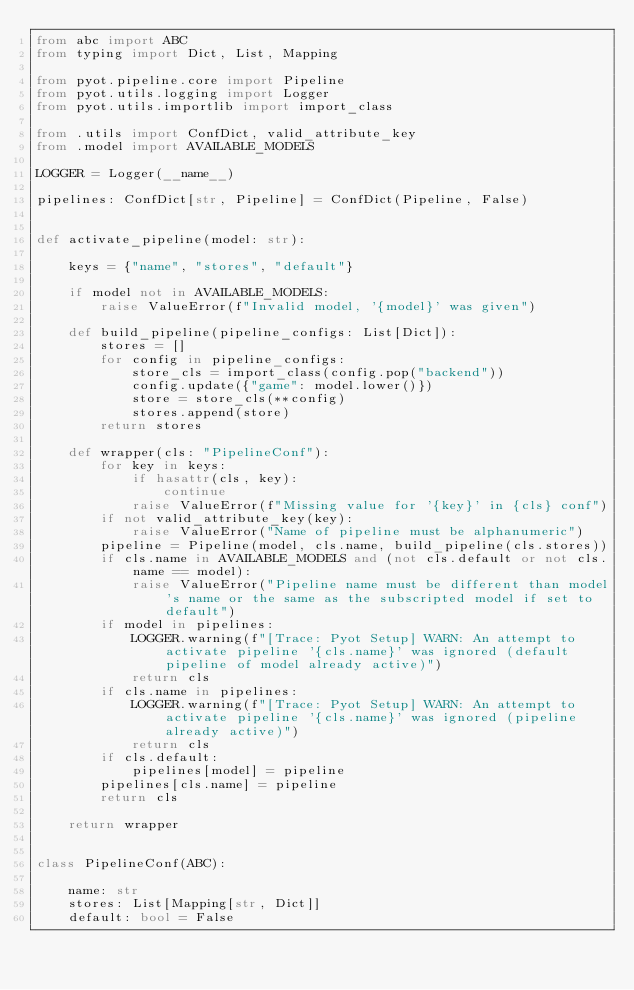Convert code to text. <code><loc_0><loc_0><loc_500><loc_500><_Python_>from abc import ABC
from typing import Dict, List, Mapping

from pyot.pipeline.core import Pipeline
from pyot.utils.logging import Logger
from pyot.utils.importlib import import_class

from .utils import ConfDict, valid_attribute_key
from .model import AVAILABLE_MODELS

LOGGER = Logger(__name__)

pipelines: ConfDict[str, Pipeline] = ConfDict(Pipeline, False)


def activate_pipeline(model: str):

    keys = {"name", "stores", "default"}

    if model not in AVAILABLE_MODELS:
        raise ValueError(f"Invalid model, '{model}' was given")

    def build_pipeline(pipeline_configs: List[Dict]):
        stores = []
        for config in pipeline_configs:
            store_cls = import_class(config.pop("backend"))
            config.update({"game": model.lower()})
            store = store_cls(**config)
            stores.append(store)
        return stores

    def wrapper(cls: "PipelineConf"):
        for key in keys:
            if hasattr(cls, key):
                continue
            raise ValueError(f"Missing value for '{key}' in {cls} conf")
        if not valid_attribute_key(key):
            raise ValueError("Name of pipeline must be alphanumeric")
        pipeline = Pipeline(model, cls.name, build_pipeline(cls.stores))
        if cls.name in AVAILABLE_MODELS and (not cls.default or not cls.name == model):
            raise ValueError("Pipeline name must be different than model's name or the same as the subscripted model if set to default")
        if model in pipelines:
            LOGGER.warning(f"[Trace: Pyot Setup] WARN: An attempt to activate pipeline '{cls.name}' was ignored (default pipeline of model already active)")
            return cls
        if cls.name in pipelines:
            LOGGER.warning(f"[Trace: Pyot Setup] WARN: An attempt to activate pipeline '{cls.name}' was ignored (pipeline already active)")
            return cls
        if cls.default:
            pipelines[model] = pipeline
        pipelines[cls.name] = pipeline
        return cls

    return wrapper


class PipelineConf(ABC):

    name: str
    stores: List[Mapping[str, Dict]]
    default: bool = False
</code> 